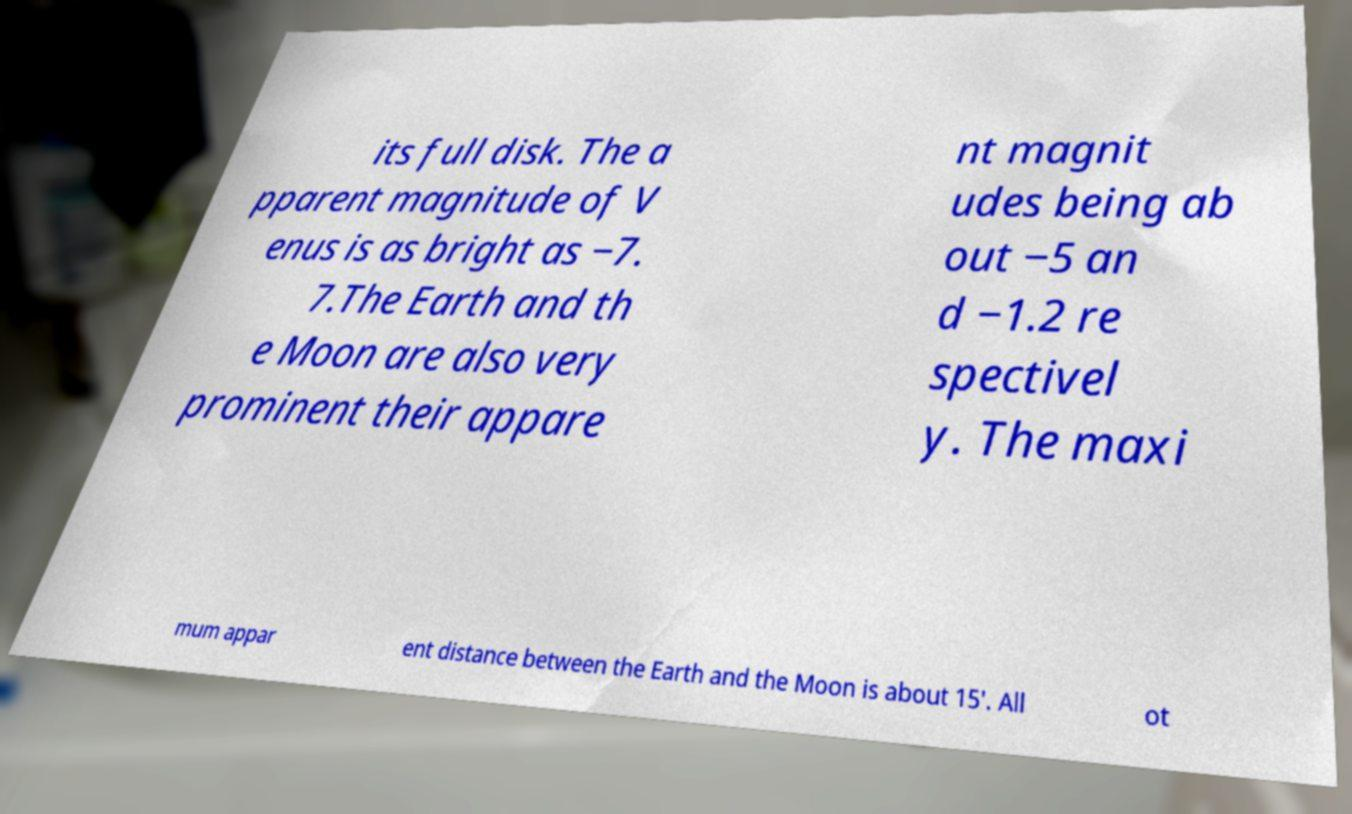Please read and relay the text visible in this image. What does it say? its full disk. The a pparent magnitude of V enus is as bright as −7. 7.The Earth and th e Moon are also very prominent their appare nt magnit udes being ab out −5 an d −1.2 re spectivel y. The maxi mum appar ent distance between the Earth and the Moon is about 15′. All ot 